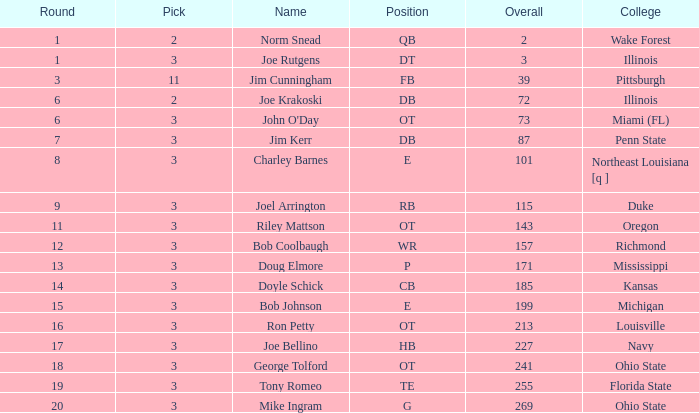How many rounds have john o'day as the name, and a pick less than 3? None. 